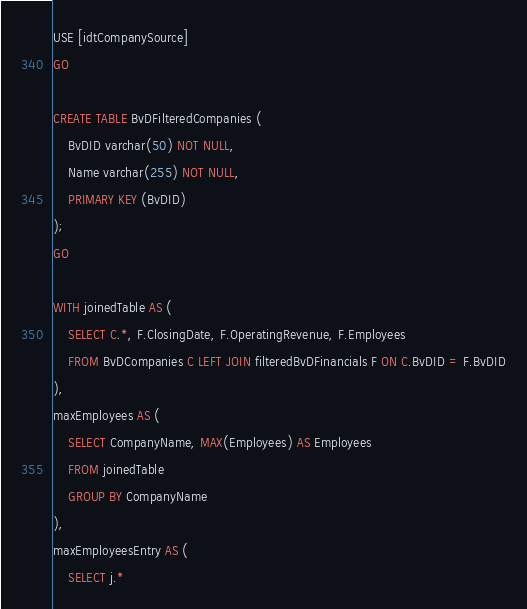Convert code to text. <code><loc_0><loc_0><loc_500><loc_500><_SQL_>USE [idtCompanySource]
GO

CREATE TABLE BvDFilteredCompanies (
    BvDID varchar(50) NOT NULL,
    Name varchar(255) NOT NULL,
    PRIMARY KEY (BvDID)
);
GO

WITH joinedTable AS (
    SELECT C.*, F.ClosingDate, F.OperatingRevenue, F.Employees
    FROM BvDCompanies C LEFT JOIN filteredBvDFinancials F ON C.BvDID = F.BvDID
),
maxEmployees AS (
    SELECT CompanyName, MAX(Employees) AS Employees
    FROM joinedTable
    GROUP BY CompanyName
),
maxEmployeesEntry AS (
    SELECT j.*</code> 